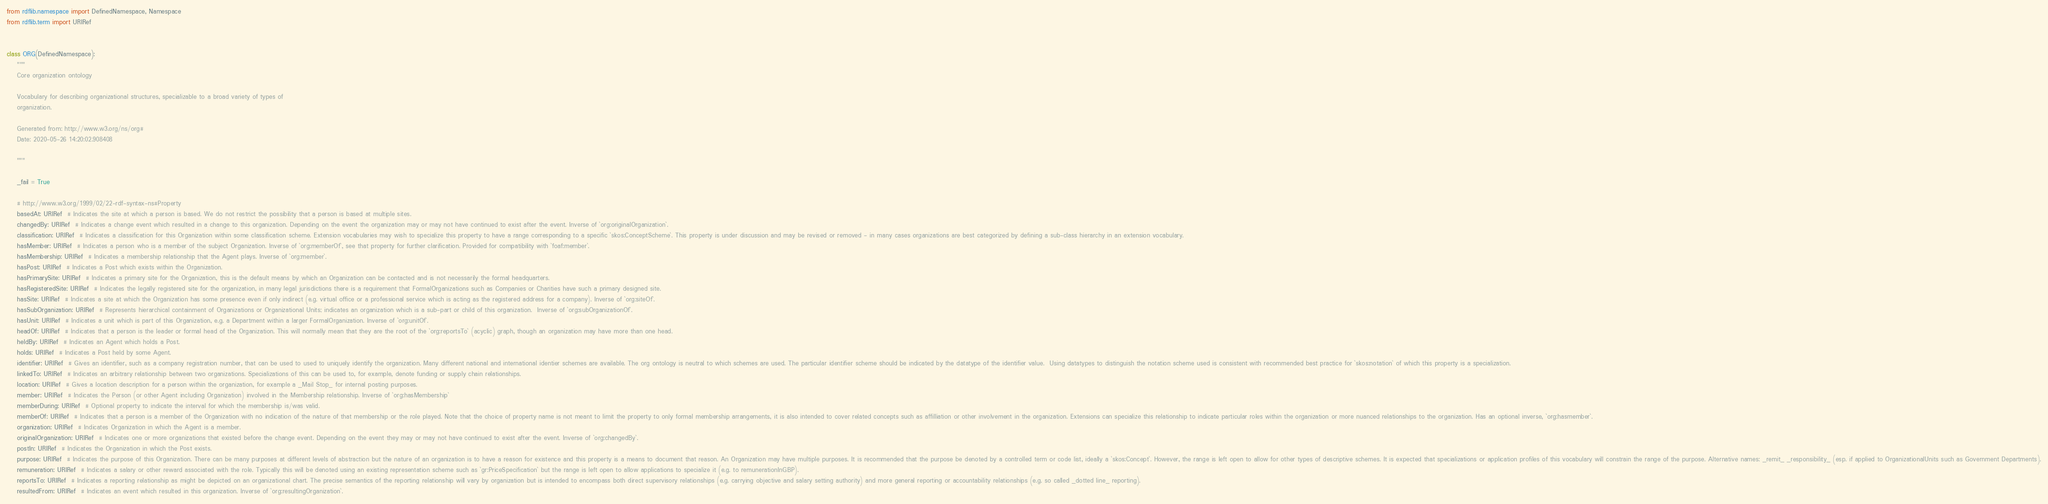Convert code to text. <code><loc_0><loc_0><loc_500><loc_500><_Python_>from rdflib.namespace import DefinedNamespace, Namespace
from rdflib.term import URIRef


class ORG(DefinedNamespace):
    """
    Core organization ontology

    Vocabulary for describing organizational structures, specializable to a broad variety of types of
    organization.

    Generated from: http://www.w3.org/ns/org#
    Date: 2020-05-26 14:20:02.908408

    """

    _fail = True

    # http://www.w3.org/1999/02/22-rdf-syntax-ns#Property
    basedAt: URIRef  # Indicates the site at which a person is based. We do not restrict the possibility that a person is based at multiple sites.
    changedBy: URIRef  # Indicates a change event which resulted in a change to this organization. Depending on the event the organization may or may not have continued to exist after the event. Inverse of `org:originalOrganization`.
    classification: URIRef  # Indicates a classification for this Organization within some classification scheme. Extension vocabularies may wish to specialize this property to have a range corresponding to a specific `skos:ConceptScheme`. This property is under discussion and may be revised or removed - in many cases organizations are best categorized by defining a sub-class hierarchy in an extension vocabulary.
    hasMember: URIRef  # Indicates a person who is a member of the subject Organization. Inverse of `org:memberOf`, see that property for further clarification. Provided for compatibility with `foaf:member`.
    hasMembership: URIRef  # Indicates a membership relationship that the Agent plays. Inverse of `org:member`.
    hasPost: URIRef  # Indicates a Post which exists within the Organization.
    hasPrimarySite: URIRef  # Indicates a primary site for the Organization, this is the default means by which an Organization can be contacted and is not necessarily the formal headquarters.
    hasRegisteredSite: URIRef  # Indicates the legally registered site for the organization, in many legal jurisdictions there is a requirement that FormalOrganizations such as Companies or Charities have such a primary designed site.
    hasSite: URIRef  # Indicates a site at which the Organization has some presence even if only indirect (e.g. virtual office or a professional service which is acting as the registered address for a company). Inverse of `org:siteOf`.
    hasSubOrganization: URIRef  # Represents hierarchical containment of Organizations or Organizational Units; indicates an organization which is a sub-part or child of this organization.  Inverse of `org:subOrganizationOf`.
    hasUnit: URIRef  # Indicates a unit which is part of this Organization, e.g. a Department within a larger FormalOrganization. Inverse of `org:unitOf`.
    headOf: URIRef  # Indicates that a person is the leader or formal head of the Organization. This will normally mean that they are the root of the `org:reportsTo` (acyclic) graph, though an organization may have more than one head.
    heldBy: URIRef  # Indicates an Agent which holds a Post.
    holds: URIRef  # Indicates a Post held by some Agent.
    identifier: URIRef  # Gives an identifier, such as a company registration number, that can be used to used to uniquely identify the organization. Many different national and international identier schemes are available. The org ontology is neutral to which schemes are used. The particular identifier scheme should be indicated by the datatype of the identifier value.  Using datatypes to distinguish the notation scheme used is consistent with recommended best practice for `skos:notation` of which this property is a specialization.
    linkedTo: URIRef  # Indicates an arbitrary relationship between two organizations. Specializations of this can be used to, for example, denote funding or supply chain relationships.
    location: URIRef  # Gives a location description for a person within the organization, for example a _Mail Stop_ for internal posting purposes.
    member: URIRef  # Indicates the Person (or other Agent including Organization) involved in the Membership relationship. Inverse of `org:hasMembership`
    memberDuring: URIRef  # Optional property to indicate the interval for which the membership is/was valid.
    memberOf: URIRef  # Indicates that a person is a member of the Organization with no indication of the nature of that membership or the role played. Note that the choice of property name is not meant to limit the property to only formal membership arrangements, it is also intended to cover related concepts such as affilliation or other involvement in the organization. Extensions can specialize this relationship to indicate particular roles within the organization or more nuanced relationships to the organization. Has an optional inverse, `org:hasmember`.
    organization: URIRef  # Indicates Organization in which the Agent is a member.
    originalOrganization: URIRef  # Indicates one or more organizations that existed before the change event. Depending on the event they may or may not have continued to exist after the event. Inverse of `org:changedBy`.
    postIn: URIRef  # Indicates the Organization in which the Post exists.
    purpose: URIRef  # Indicates the purpose of this Organization. There can be many purposes at different levels of abstraction but the nature of an organization is to have a reason for existence and this property is a means to document that reason. An Organization may have multiple purposes. It is recommended that the purpose be denoted by a controlled term or code list, ideally a `skos:Concept`. However, the range is left open to allow for other types of descriptive schemes. It is expected that specializations or application profiles of this vocabulary will constrain the range of the purpose. Alternative names: _remit_ _responsibility_ (esp. if applied to OrganizationalUnits such as Government Departments).
    remuneration: URIRef  # Indicates a salary or other reward associated with the role. Typically this will be denoted using an existing representation scheme such as `gr:PriceSpecification` but the range is left open to allow applications to specialize it (e.g. to remunerationInGBP).
    reportsTo: URIRef  # Indicates a reporting relationship as might be depicted on an organizational chart. The precise semantics of the reporting relationship will vary by organization but is intended to encompass both direct supervisory relationships (e.g. carrying objective and salary setting authority) and more general reporting or accountability relationships (e.g. so called _dotted line_ reporting).
    resultedFrom: URIRef  # Indicates an event which resulted in this organization. Inverse of `org:resultingOrganization`.</code> 